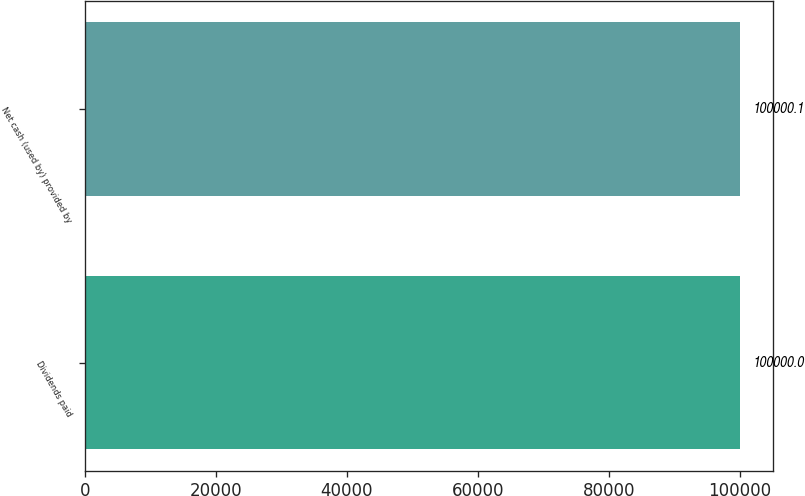Convert chart to OTSL. <chart><loc_0><loc_0><loc_500><loc_500><bar_chart><fcel>Dividends paid<fcel>Net cash (used by) provided by<nl><fcel>100000<fcel>100000<nl></chart> 